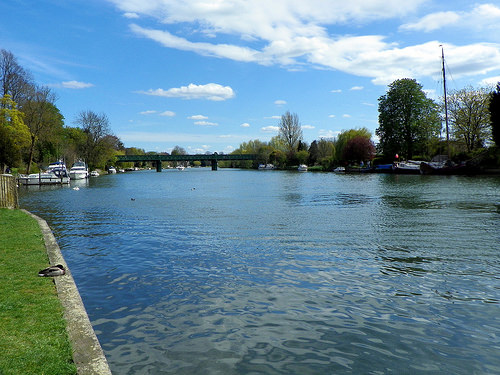<image>
Is the tree on the water? No. The tree is not positioned on the water. They may be near each other, but the tree is not supported by or resting on top of the water. 